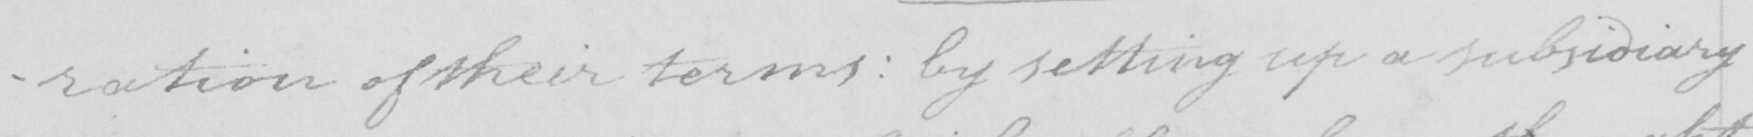Please provide the text content of this handwritten line. -ration of their terms  :  by setting up a subsidiary 